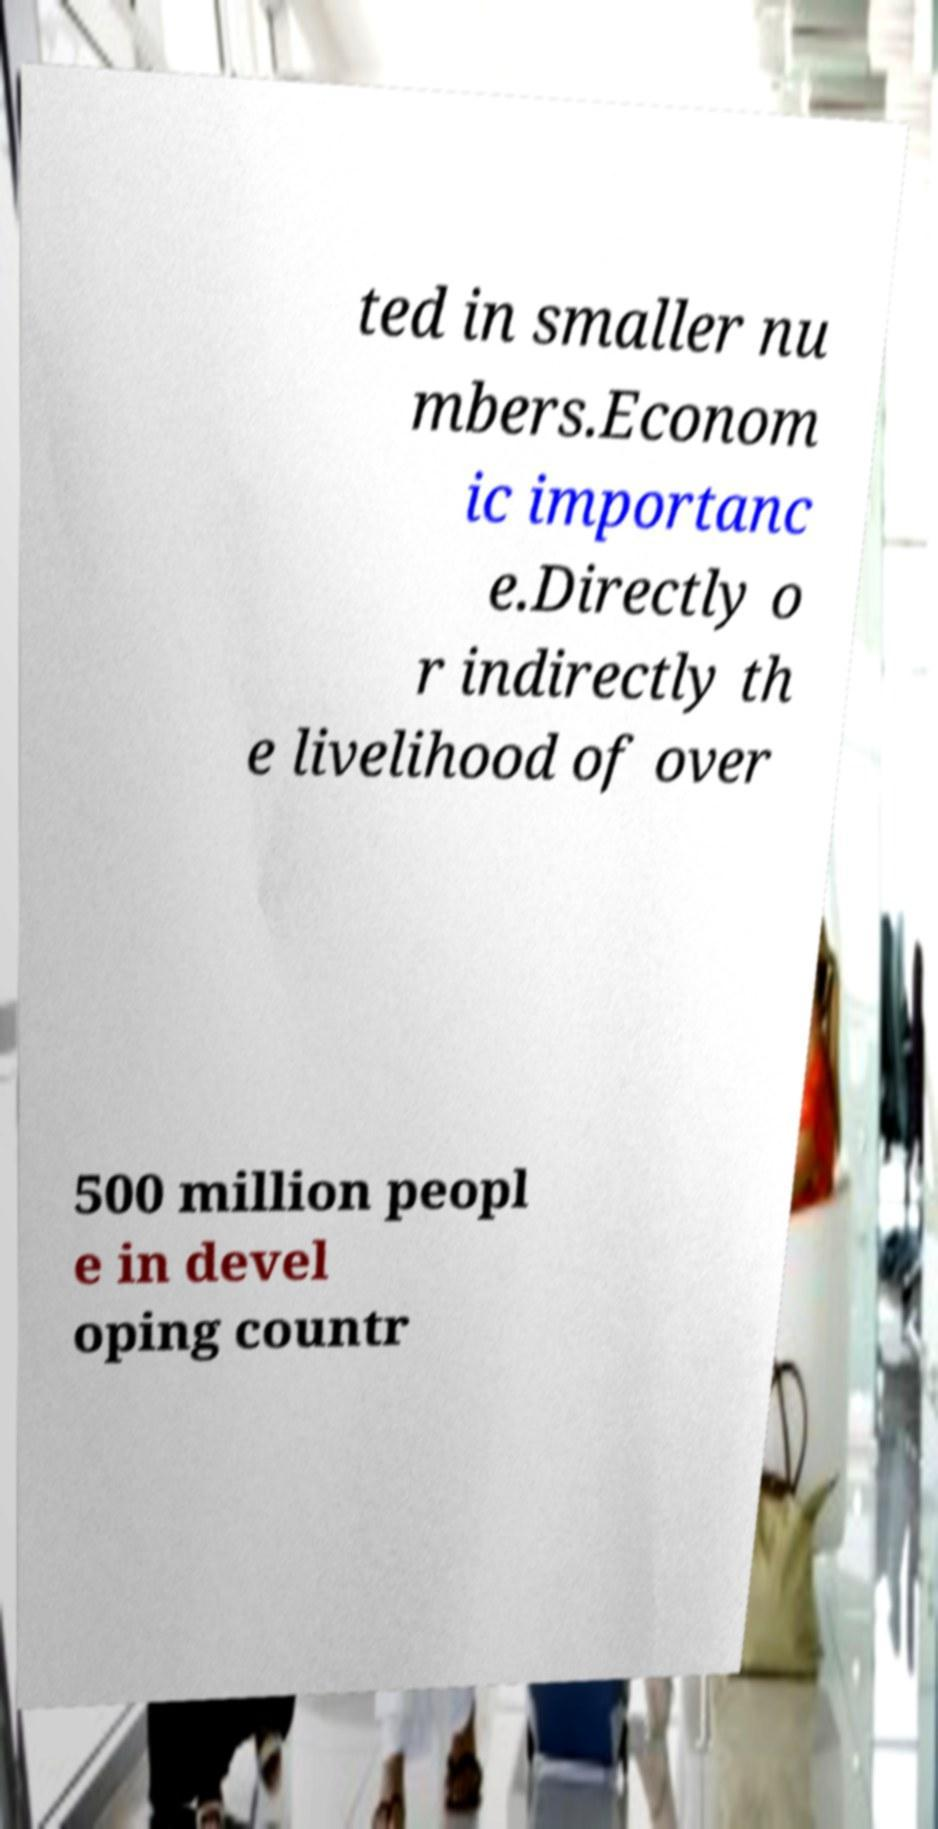Can you accurately transcribe the text from the provided image for me? ted in smaller nu mbers.Econom ic importanc e.Directly o r indirectly th e livelihood of over 500 million peopl e in devel oping countr 